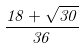Convert formula to latex. <formula><loc_0><loc_0><loc_500><loc_500>\frac { 1 8 + \sqrt { 3 0 } } { 3 6 }</formula> 